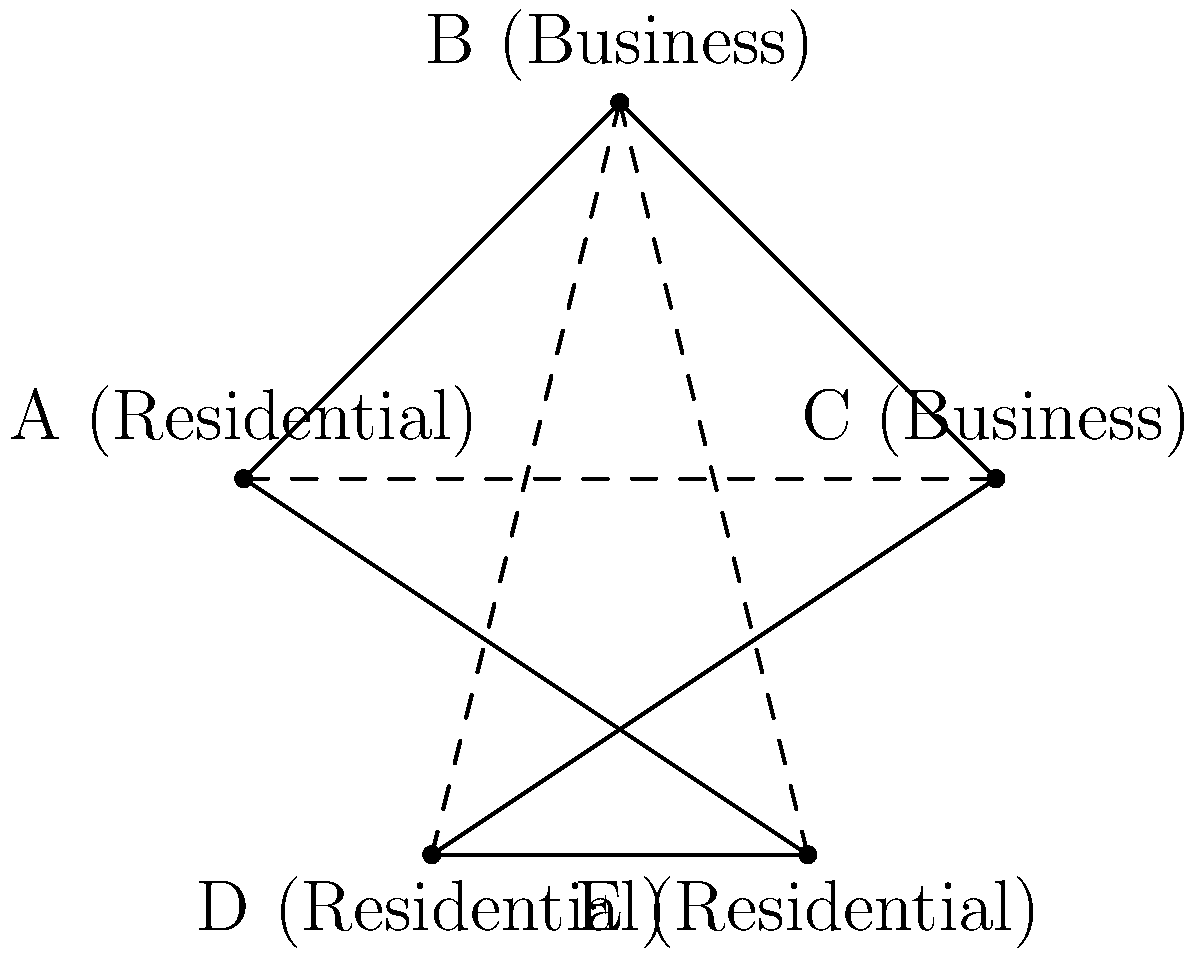Given the map of a city with residential areas (A, D, E) and business districts (B, C), which route would be most efficient for a zero-emission public transportation system connecting all points while minimizing total distance traveled? To find the most efficient route, we need to consider the following steps:

1. Identify all possible routes that connect all points.
2. Calculate the total distance for each route.
3. Choose the route with the minimum total distance.

Possible routes:
1. A-B-C-E-D-A
2. A-B-E-D-C-A
3. A-D-E-C-B-A

Let's calculate the distances:

1. A-B-C-E-D-A:
   AB + BC + CE + ED + DA = $\sqrt{8} + \sqrt{8} + \sqrt{13} + 2 + \sqrt{5}$ ≈ 10.77

2. A-B-E-D-C-A:
   AB + BE + ED + DC + CA = $\sqrt{8} + \sqrt{13} + 2 + \sqrt{8} + 4$ ≈ 11.94

3. A-D-E-C-B-A:
   AD + DE + EC + CB + BA = $\sqrt{5} + 2 + \sqrt{13} + \sqrt{8} + \sqrt{8}$ ≈ 10.77

Routes 1 and 3 have the same total distance, which is shorter than route 2. Both can be considered the most efficient routes.

For the sake of answering, we'll choose route 1: A-B-C-E-D-A.
Answer: A-B-C-E-D-A 